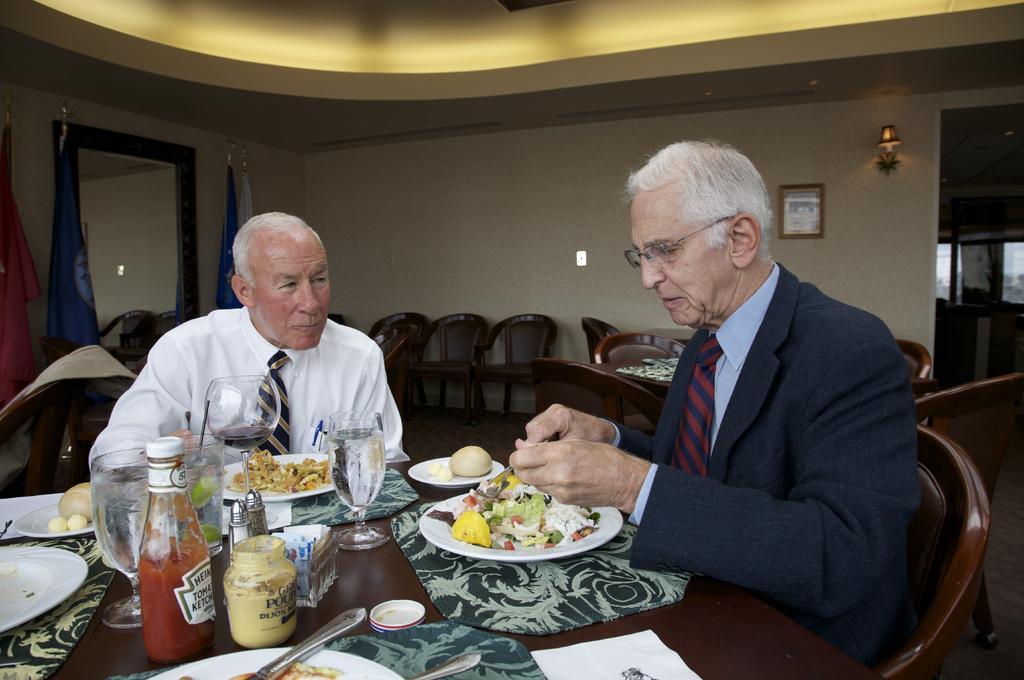In one or two sentences, can you explain what this image depicts? There are two men sitting on chairs and we can see plates, food, glasses, lid, jars, mats, bottle and objects on the table. We can see chairs and table. In the background we can see flags, frame on the wall, door and windows. 